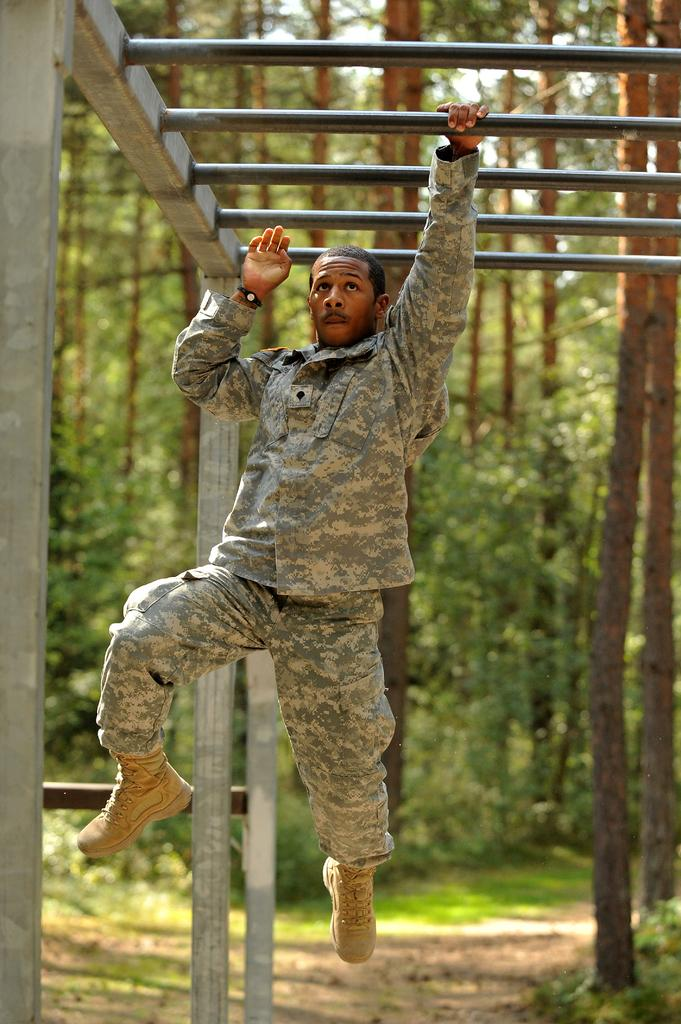What is the person in the image holding? The person is holding a rod in the image. What type of clothing is the person wearing? The person is wearing a military uniform. What can be seen in the background of the image? There are trees and the sky visible in the background of the image. What is the color of the trees in the image? The trees are green in color. What is the color of the sky in the image? The sky is white in color. Can you tell me where the clam is located in the image? There is no clam present in the image. How does the person walk while holding the rod in the image? The image does not show the person walking; it is a still image. 